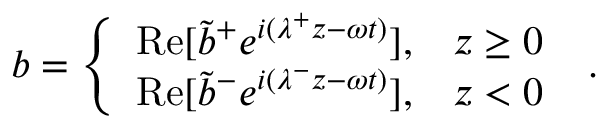Convert formula to latex. <formula><loc_0><loc_0><loc_500><loc_500>b = \left \{ \begin{array} { l l } { R e [ \tilde { b } ^ { + } e ^ { i ( \lambda ^ { + } z - \omega t ) } ] , } & { z \geq 0 } \\ { R e [ \tilde { b } ^ { - } e ^ { i ( \lambda ^ { - } z - \omega t ) } ] , } & { z < 0 } \end{array} .</formula> 